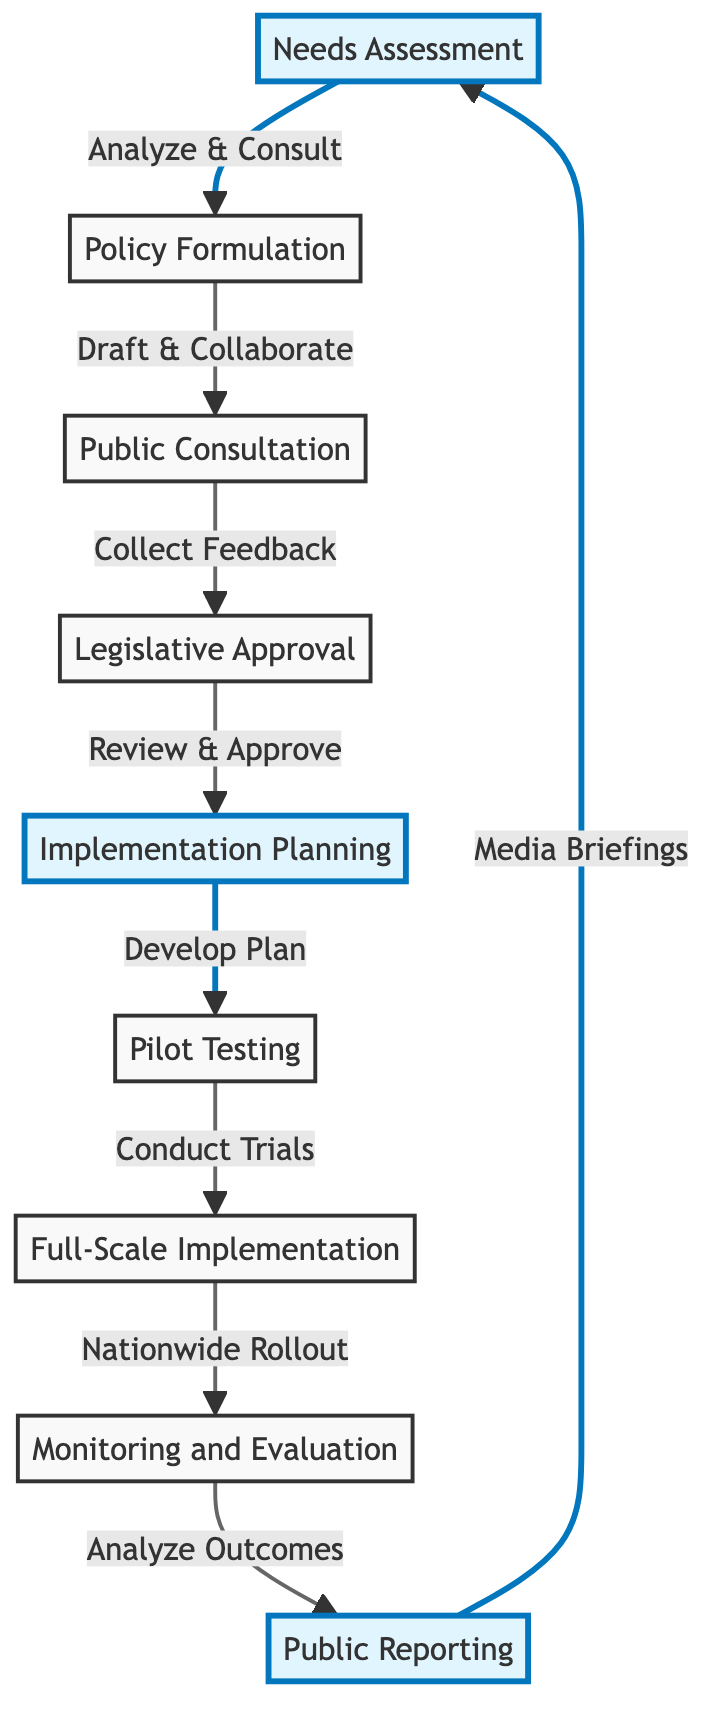What is the first step in the diagram? The diagram starts with "Needs Assessment," which is the first node and denotes the initial step of the process.
Answer: Needs Assessment How many steps are there in total? Counting all the distinct steps from "Needs Assessment" to "Public Reporting," there are nine individual steps reflected in the diagram.
Answer: Nine What follows after Public Consultation? Following "Public Consultation," the next step indicated in the diagram is "Legislative Approval," showing the flow of the process.
Answer: Legislative Approval Which steps are highlighted in the diagram? The diagram highlights three specific steps: "Needs Assessment," "Implementation Planning," and "Public Reporting," which are visually distinguished from others.
Answer: Needs Assessment, Implementation Planning, Public Reporting What is the relationship between Implementation Planning and Pilot Testing? The arrow from "Implementation Planning" to "Pilot Testing" indicates that after planning, the next action is to conduct "Pilot Testing," which shows the sequential flow between these steps.
Answer: Conduct Trials What type of feedback is collected during Public Consultation? The diagram specifies that during "Public Consultation," feedback is collected through forums and surveys, which indicates the methods used for engagement.
Answer: Forums and Surveys How does Monitoring and Evaluation relate to Public Reporting? "Monitoring and Evaluation" leads to "Public Reporting," meaning that the outcomes of the monitoring phase directly inform and shape the public communications process.
Answer: Analyze Outcomes Which step involves drafting policy proposals? The step noted for drafting policy proposals is "Policy Formulation," where collaboration with experts occurs.
Answer: Policy Formulation Is there a step that involves trials before full implementation? Yes, "Pilot Testing" is the step specifically dedicated to conducting trials in selected regions prior to the full rollout of the policy.
Answer: Pilot Testing 